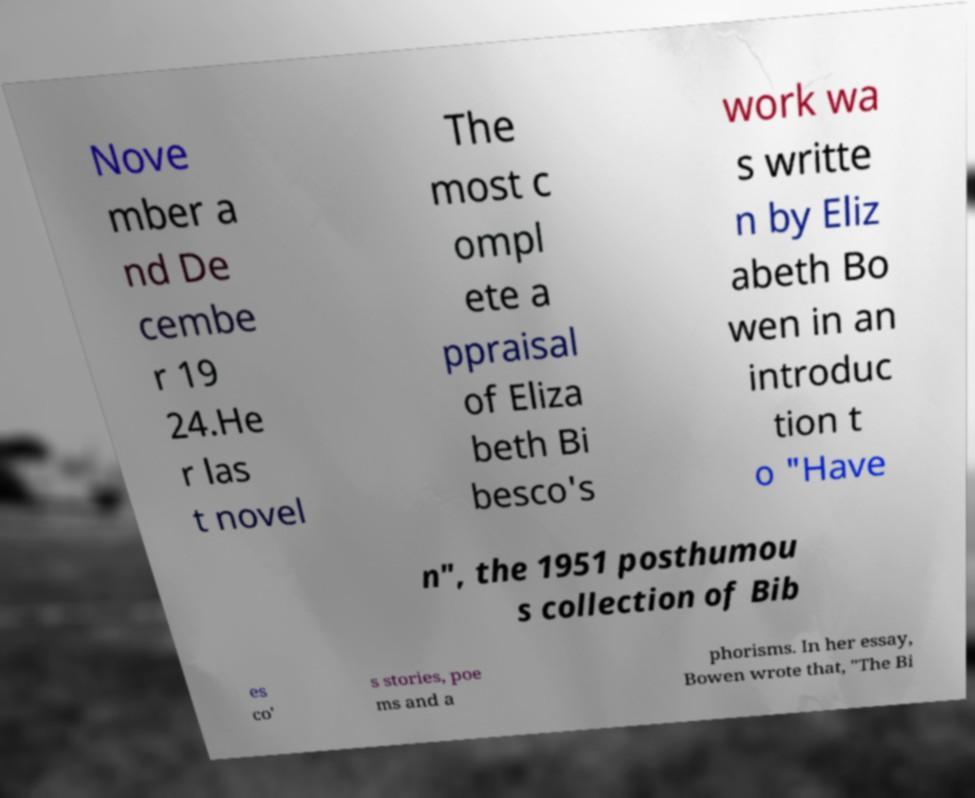Could you extract and type out the text from this image? Nove mber a nd De cembe r 19 24.He r las t novel The most c ompl ete a ppraisal of Eliza beth Bi besco's work wa s writte n by Eliz abeth Bo wen in an introduc tion t o "Have n", the 1951 posthumou s collection of Bib es co' s stories, poe ms and a phorisms. In her essay, Bowen wrote that, "The Bi 